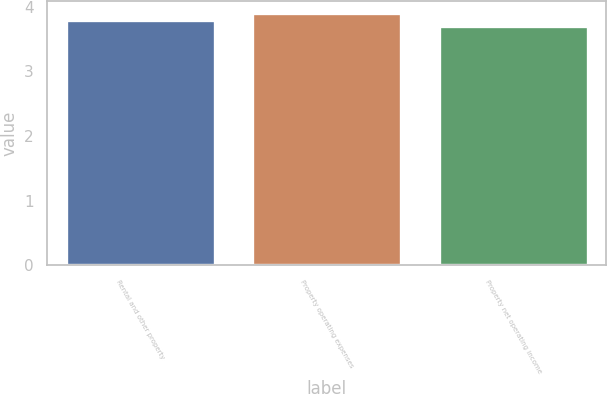Convert chart. <chart><loc_0><loc_0><loc_500><loc_500><bar_chart><fcel>Rental and other property<fcel>Property operating expenses<fcel>Property net operating income<nl><fcel>3.8<fcel>3.9<fcel>3.7<nl></chart> 